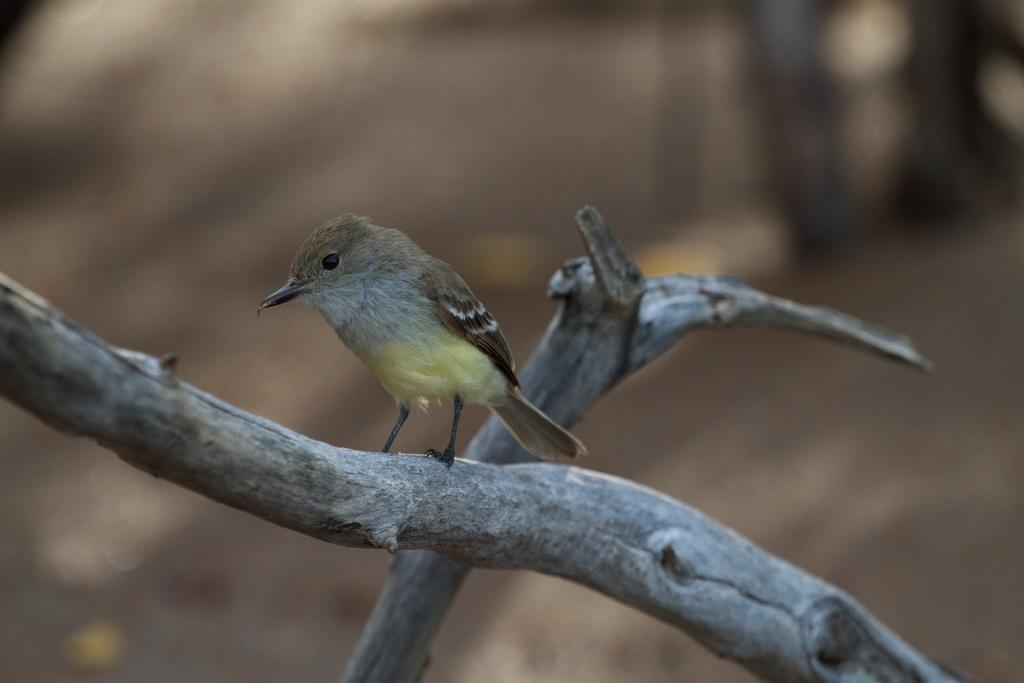What type of animal is in the image? There is a bird in the image. Where is the bird located? The bird is sitting on a stem. Can you describe the background of the image? The background of the image is blurred. How much wealth does the bird possess in the image? There is no indication of wealth in the image, as it features a bird sitting on a stem with a blurred background. Can you describe the bird's kissing technique in the image? There is no kissing activity depicted in the image; it simply shows a bird sitting on a stem. 